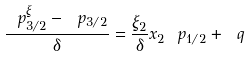<formula> <loc_0><loc_0><loc_500><loc_500>\frac { \ p _ { 3 / 2 } ^ { \xi } - \ p _ { 3 / 2 } } { \delta } = \frac { \xi _ { 2 } } { \delta } x _ { 2 } \ p _ { 1 / 2 } + \ q</formula> 